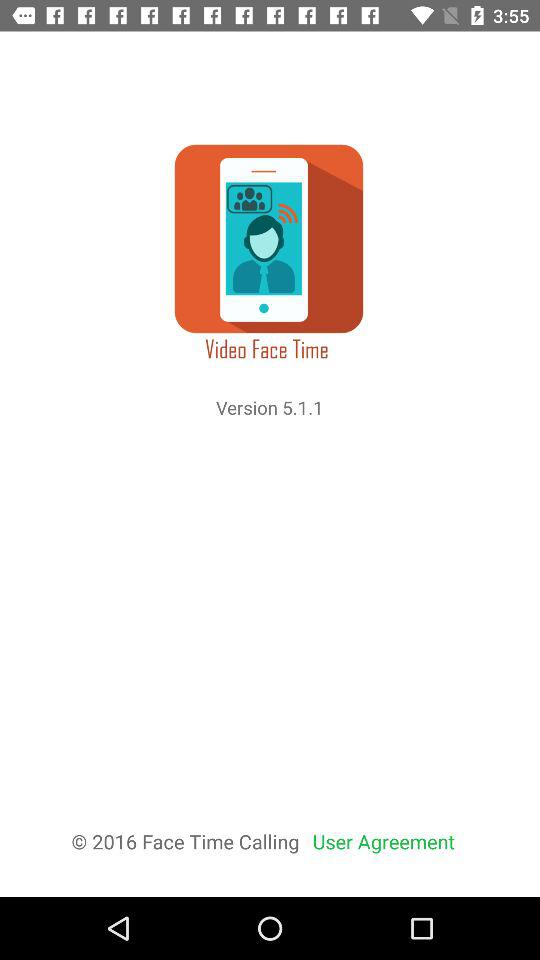What is the name of the application? The name of the application is "Video Face Time". 